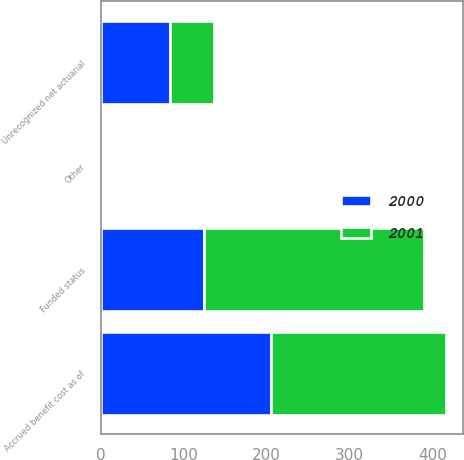Convert chart to OTSL. <chart><loc_0><loc_0><loc_500><loc_500><stacked_bar_chart><ecel><fcel>Funded status<fcel>Unrecognized net actuarial<fcel>Other<fcel>Accrued benefit cost as of<nl><fcel>2001<fcel>265<fcel>53<fcel>2<fcel>210<nl><fcel>2000<fcel>125<fcel>84<fcel>3<fcel>206<nl></chart> 